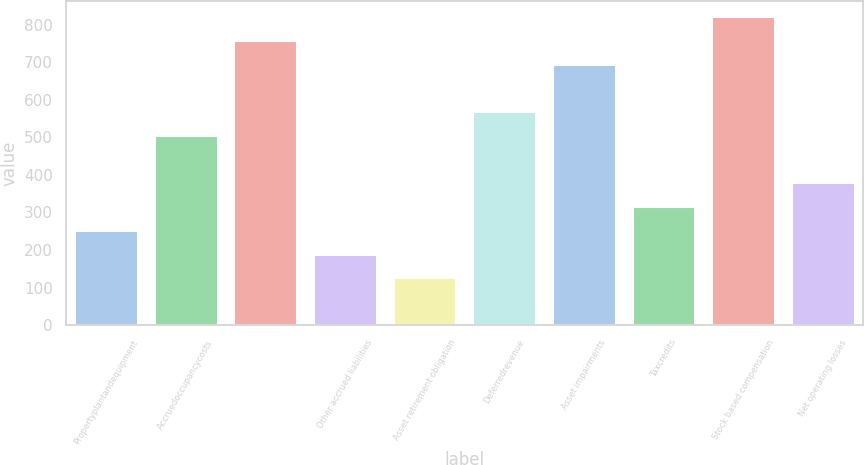Convert chart to OTSL. <chart><loc_0><loc_0><loc_500><loc_500><bar_chart><fcel>Propertyplantandequipment<fcel>Accruedoccupancycosts<fcel>Unnamed: 2<fcel>Other accrued liabilities<fcel>Asset retirement obligation<fcel>Deferredrevenue<fcel>Asset impairments<fcel>Taxcredits<fcel>Stock based compensation<fcel>Net operating losses<nl><fcel>253.38<fcel>506.38<fcel>759.38<fcel>190.13<fcel>126.88<fcel>569.63<fcel>696.13<fcel>316.63<fcel>822.63<fcel>379.88<nl></chart> 